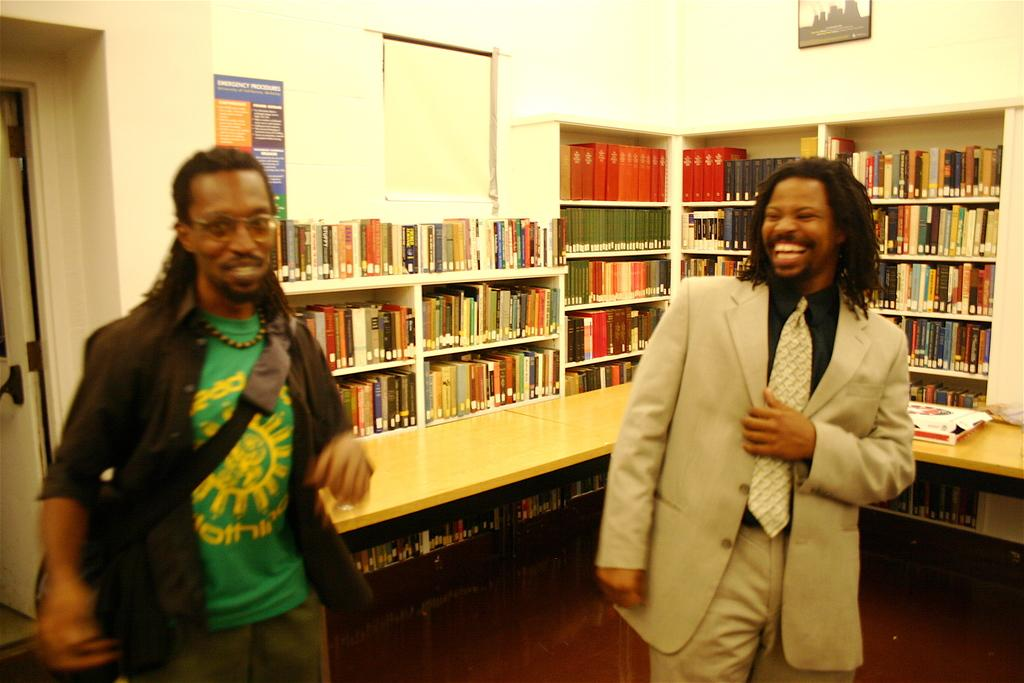How many people are in the image? There are two people in the image. What is the facial expression of the people in the image? The people are smiling. What can be seen in the background of the image? There is a wooden platform, shelves with books, a wall with a photo frame and a poster, and some objects in the background. What type of coil is being used to catch the fish in the image? There is no coil or fish present in the image. The image features two people smiling, a wooden platform, shelves with books, a wall with a photo frame and a poster, and some objects in the background. 